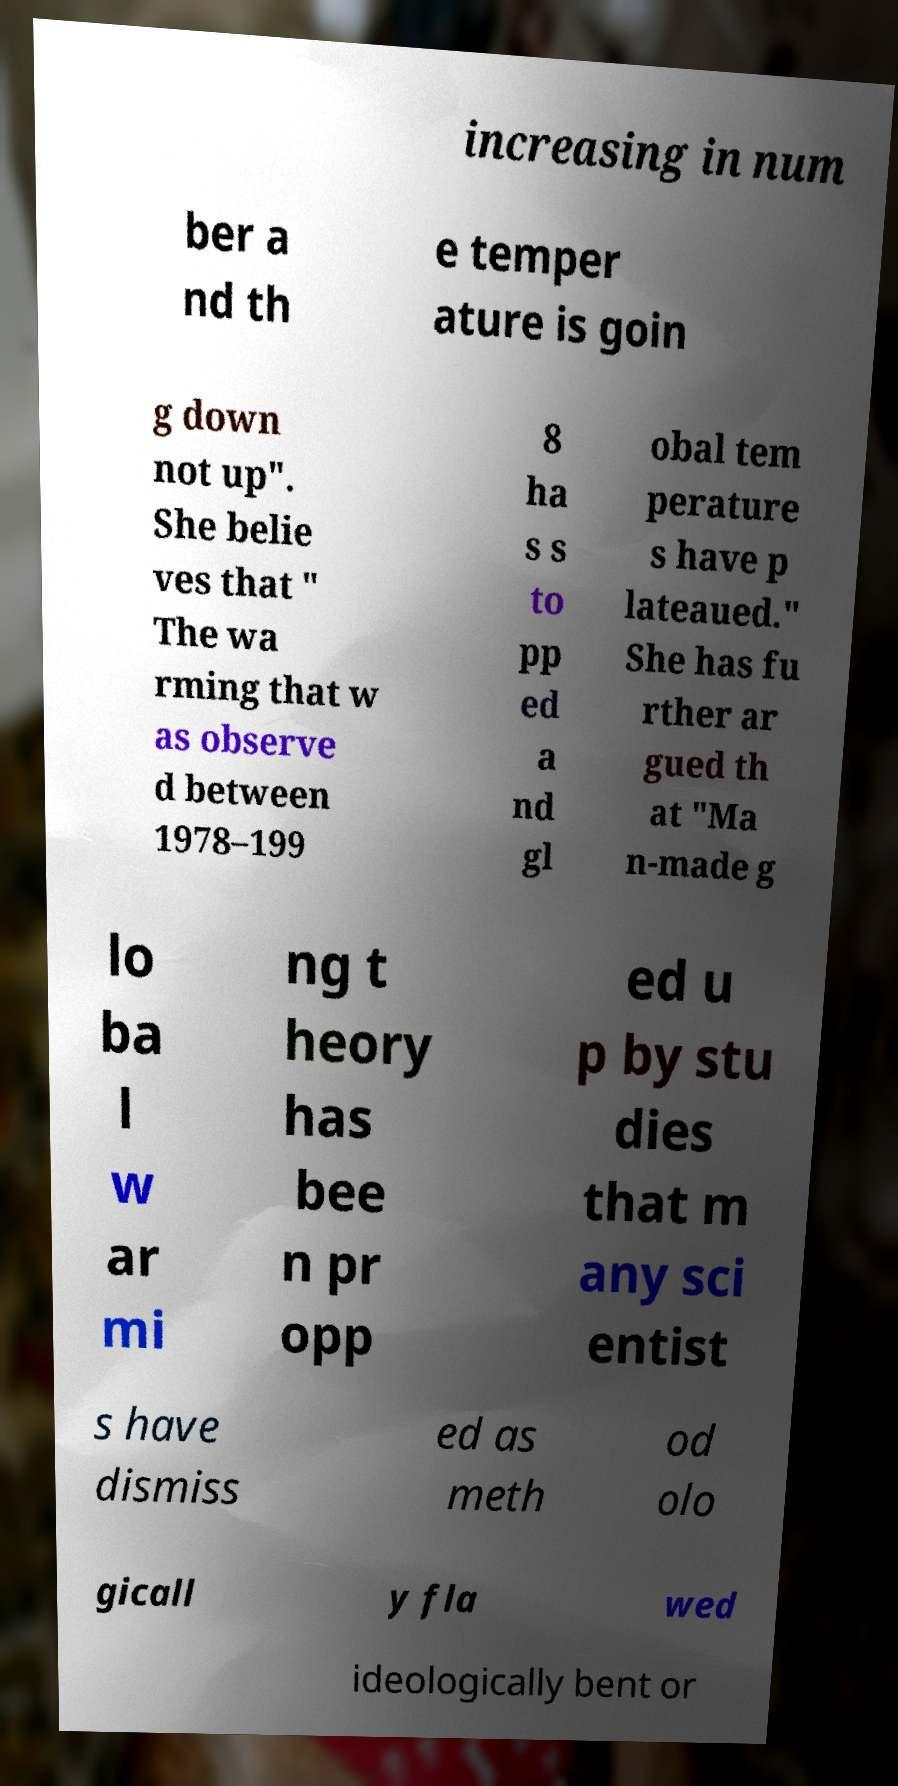Could you extract and type out the text from this image? increasing in num ber a nd th e temper ature is goin g down not up". She belie ves that " The wa rming that w as observe d between 1978–199 8 ha s s to pp ed a nd gl obal tem perature s have p lateaued." She has fu rther ar gued th at "Ma n-made g lo ba l w ar mi ng t heory has bee n pr opp ed u p by stu dies that m any sci entist s have dismiss ed as meth od olo gicall y fla wed ideologically bent or 